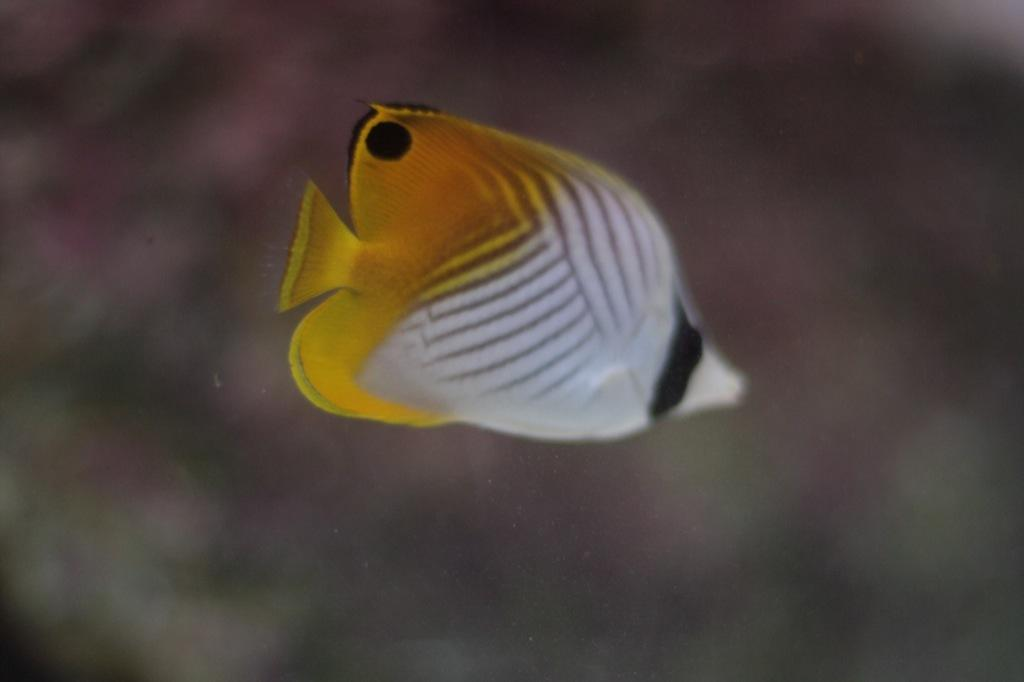What type of animals can be seen in the image? There are fish in the image. What colors are the fish? The fish are white, yellow, and black in color. Can you describe the background of the image? The background of the image is blurred. What type of rings can be seen on the doctor's fingers in the image? There is no doctor or rings present in the image; it features fish with a blurred background. 